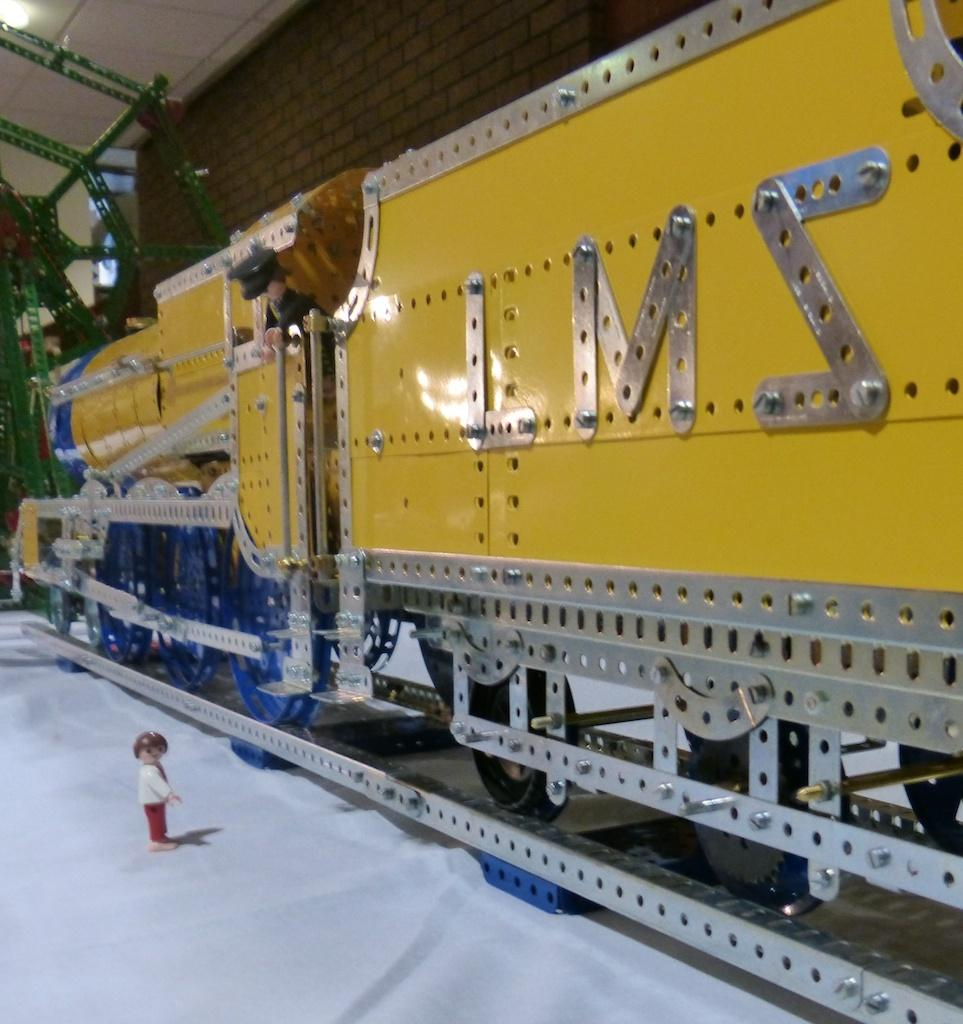<image>
Share a concise interpretation of the image provided. a big model train with LMZ on the side with a lego person next to it 